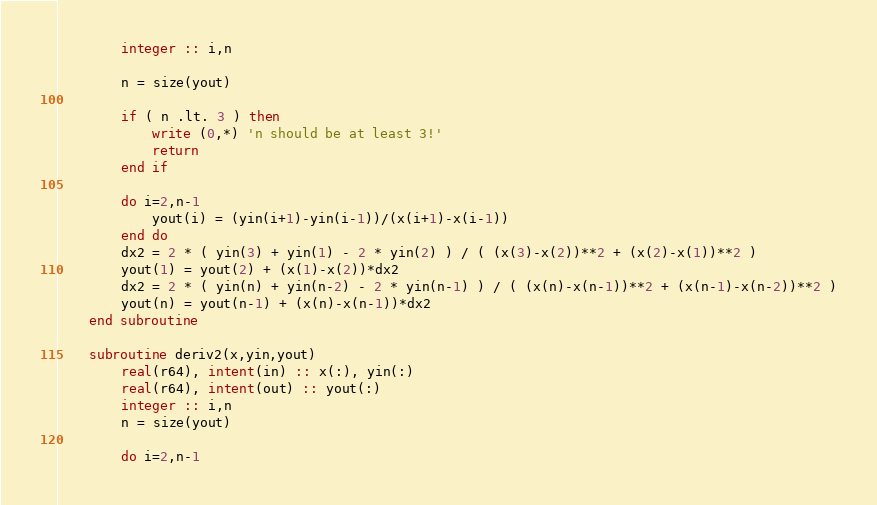Convert code to text. <code><loc_0><loc_0><loc_500><loc_500><_FORTRAN_>        integer :: i,n

        n = size(yout)

        if ( n .lt. 3 ) then
            write (0,*) 'n should be at least 3!'
            return
        end if

        do i=2,n-1
            yout(i) = (yin(i+1)-yin(i-1))/(x(i+1)-x(i-1))
        end do
        dx2 = 2 * ( yin(3) + yin(1) - 2 * yin(2) ) / ( (x(3)-x(2))**2 + (x(2)-x(1))**2 )
        yout(1) = yout(2) + (x(1)-x(2))*dx2
        dx2 = 2 * ( yin(n) + yin(n-2) - 2 * yin(n-1) ) / ( (x(n)-x(n-1))**2 + (x(n-1)-x(n-2))**2 )
        yout(n) = yout(n-1) + (x(n)-x(n-1))*dx2
    end subroutine

    subroutine deriv2(x,yin,yout)
        real(r64), intent(in) :: x(:), yin(:)
        real(r64), intent(out) :: yout(:)
        integer :: i,n
        n = size(yout)

        do i=2,n-1</code> 